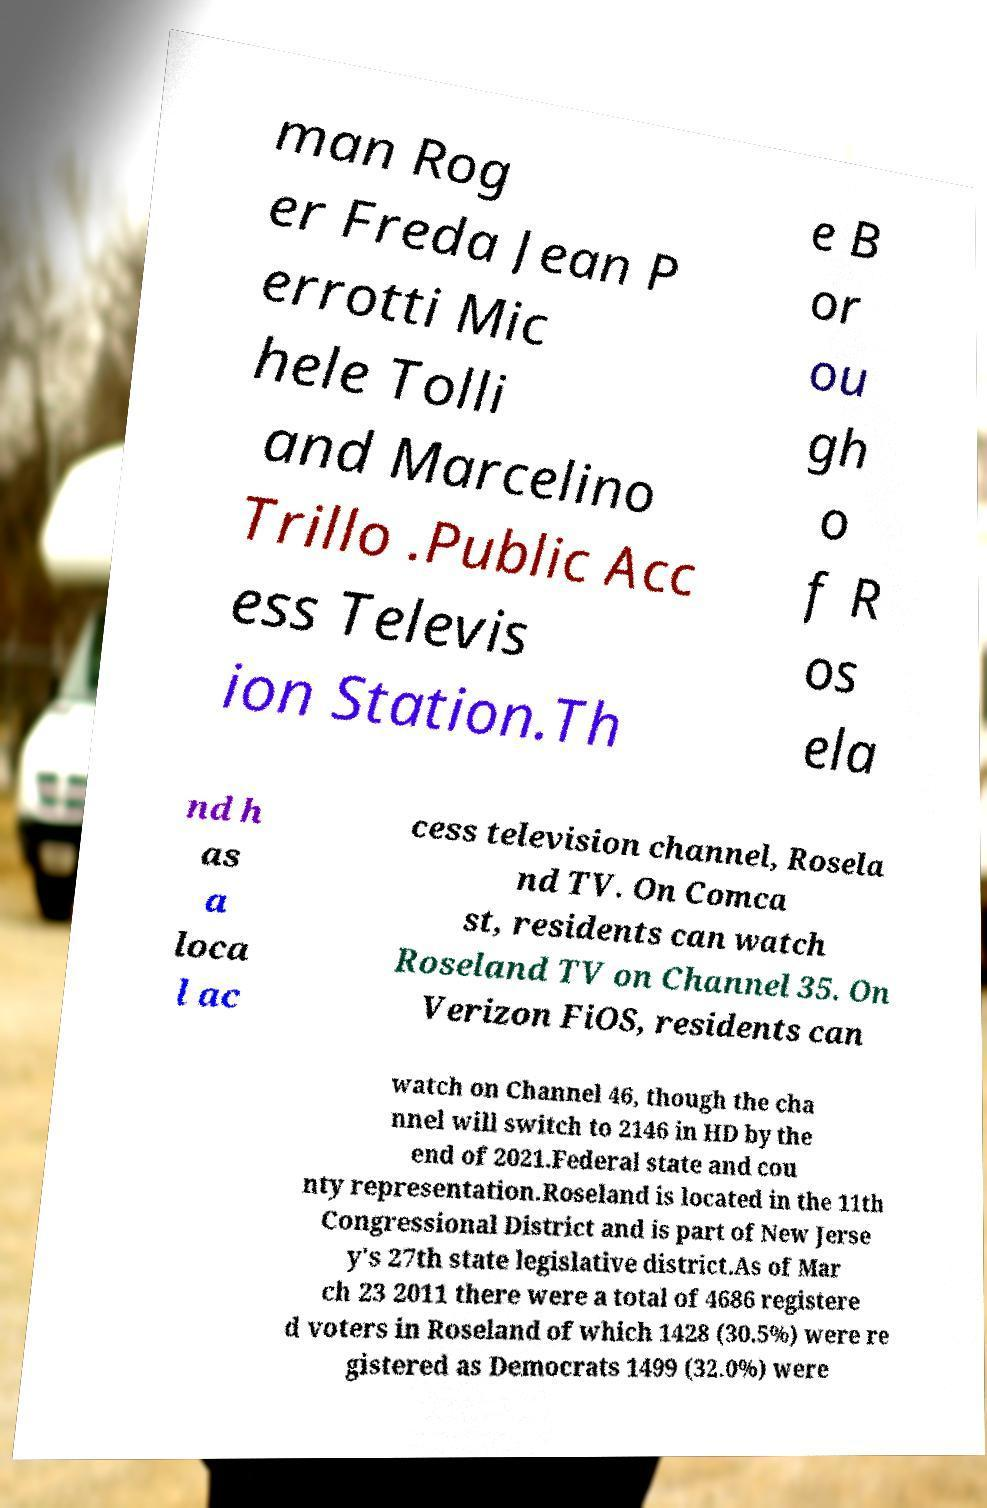Could you assist in decoding the text presented in this image and type it out clearly? man Rog er Freda Jean P errotti Mic hele Tolli and Marcelino Trillo .Public Acc ess Televis ion Station.Th e B or ou gh o f R os ela nd h as a loca l ac cess television channel, Rosela nd TV. On Comca st, residents can watch Roseland TV on Channel 35. On Verizon FiOS, residents can watch on Channel 46, though the cha nnel will switch to 2146 in HD by the end of 2021.Federal state and cou nty representation.Roseland is located in the 11th Congressional District and is part of New Jerse y's 27th state legislative district.As of Mar ch 23 2011 there were a total of 4686 registere d voters in Roseland of which 1428 (30.5%) were re gistered as Democrats 1499 (32.0%) were 